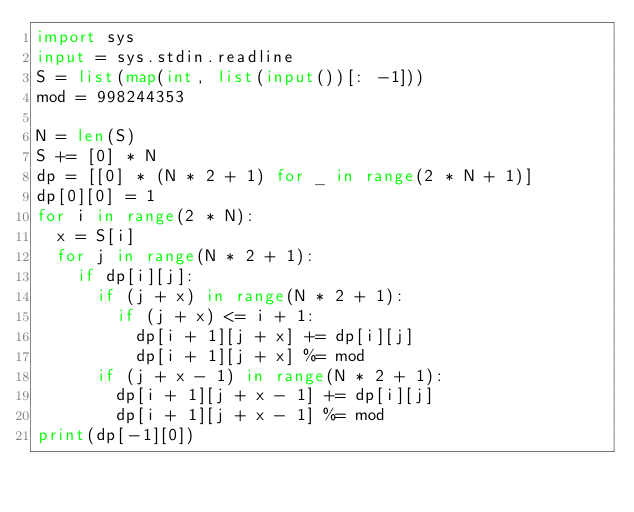Convert code to text. <code><loc_0><loc_0><loc_500><loc_500><_Python_>import sys
input = sys.stdin.readline
S = list(map(int, list(input())[: -1]))
mod = 998244353

N = len(S)
S += [0] * N
dp = [[0] * (N * 2 + 1) for _ in range(2 * N + 1)]
dp[0][0] = 1
for i in range(2 * N):
  x = S[i]
  for j in range(N * 2 + 1):
    if dp[i][j]:
      if (j + x) in range(N * 2 + 1):
        if (j + x) <= i + 1:
          dp[i + 1][j + x] += dp[i][j]
          dp[i + 1][j + x] %= mod
      if (j + x - 1) in range(N * 2 + 1):
        dp[i + 1][j + x - 1] += dp[i][j]
        dp[i + 1][j + x - 1] %= mod
print(dp[-1][0])</code> 